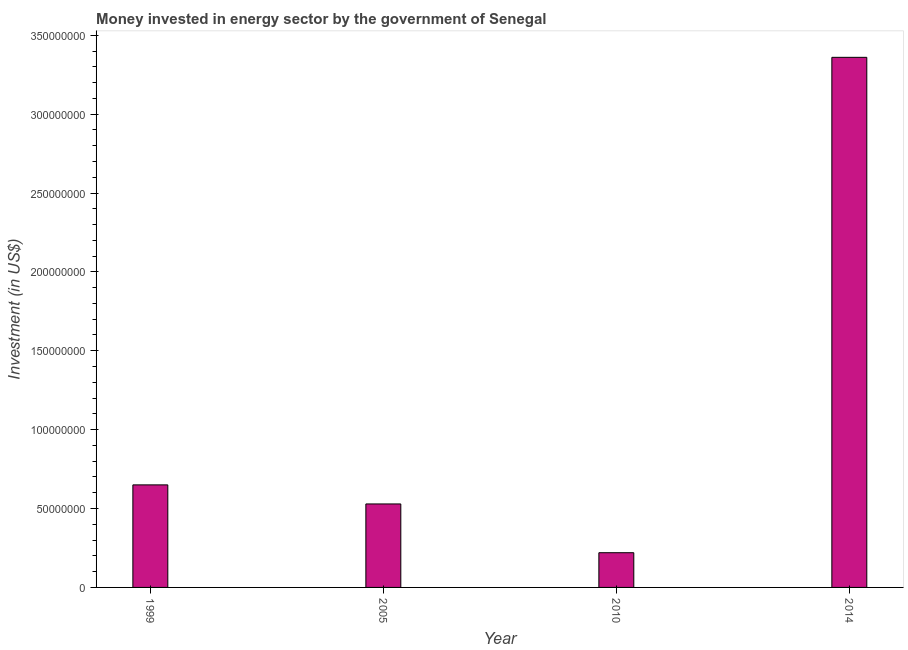Does the graph contain grids?
Your answer should be very brief. No. What is the title of the graph?
Keep it short and to the point. Money invested in energy sector by the government of Senegal. What is the label or title of the X-axis?
Give a very brief answer. Year. What is the label or title of the Y-axis?
Your answer should be compact. Investment (in US$). What is the investment in energy in 2014?
Ensure brevity in your answer.  3.36e+08. Across all years, what is the maximum investment in energy?
Your answer should be compact. 3.36e+08. Across all years, what is the minimum investment in energy?
Provide a succinct answer. 2.20e+07. What is the sum of the investment in energy?
Give a very brief answer. 4.76e+08. What is the difference between the investment in energy in 1999 and 2005?
Ensure brevity in your answer.  1.21e+07. What is the average investment in energy per year?
Keep it short and to the point. 1.19e+08. What is the median investment in energy?
Give a very brief answer. 5.90e+07. In how many years, is the investment in energy greater than 20000000 US$?
Your response must be concise. 4. What is the ratio of the investment in energy in 1999 to that in 2014?
Provide a succinct answer. 0.19. Is the investment in energy in 1999 less than that in 2014?
Your response must be concise. Yes. What is the difference between the highest and the second highest investment in energy?
Provide a succinct answer. 2.71e+08. Is the sum of the investment in energy in 1999 and 2014 greater than the maximum investment in energy across all years?
Your answer should be compact. Yes. What is the difference between the highest and the lowest investment in energy?
Make the answer very short. 3.14e+08. How many bars are there?
Keep it short and to the point. 4. Are all the bars in the graph horizontal?
Your answer should be compact. No. What is the difference between two consecutive major ticks on the Y-axis?
Keep it short and to the point. 5.00e+07. What is the Investment (in US$) of 1999?
Give a very brief answer. 6.50e+07. What is the Investment (in US$) in 2005?
Provide a succinct answer. 5.29e+07. What is the Investment (in US$) of 2010?
Give a very brief answer. 2.20e+07. What is the Investment (in US$) in 2014?
Offer a very short reply. 3.36e+08. What is the difference between the Investment (in US$) in 1999 and 2005?
Your answer should be very brief. 1.21e+07. What is the difference between the Investment (in US$) in 1999 and 2010?
Your answer should be compact. 4.30e+07. What is the difference between the Investment (in US$) in 1999 and 2014?
Your response must be concise. -2.71e+08. What is the difference between the Investment (in US$) in 2005 and 2010?
Keep it short and to the point. 3.09e+07. What is the difference between the Investment (in US$) in 2005 and 2014?
Keep it short and to the point. -2.83e+08. What is the difference between the Investment (in US$) in 2010 and 2014?
Ensure brevity in your answer.  -3.14e+08. What is the ratio of the Investment (in US$) in 1999 to that in 2005?
Give a very brief answer. 1.23. What is the ratio of the Investment (in US$) in 1999 to that in 2010?
Offer a very short reply. 2.96. What is the ratio of the Investment (in US$) in 1999 to that in 2014?
Your response must be concise. 0.19. What is the ratio of the Investment (in US$) in 2005 to that in 2010?
Ensure brevity in your answer.  2.4. What is the ratio of the Investment (in US$) in 2005 to that in 2014?
Keep it short and to the point. 0.16. What is the ratio of the Investment (in US$) in 2010 to that in 2014?
Offer a very short reply. 0.07. 